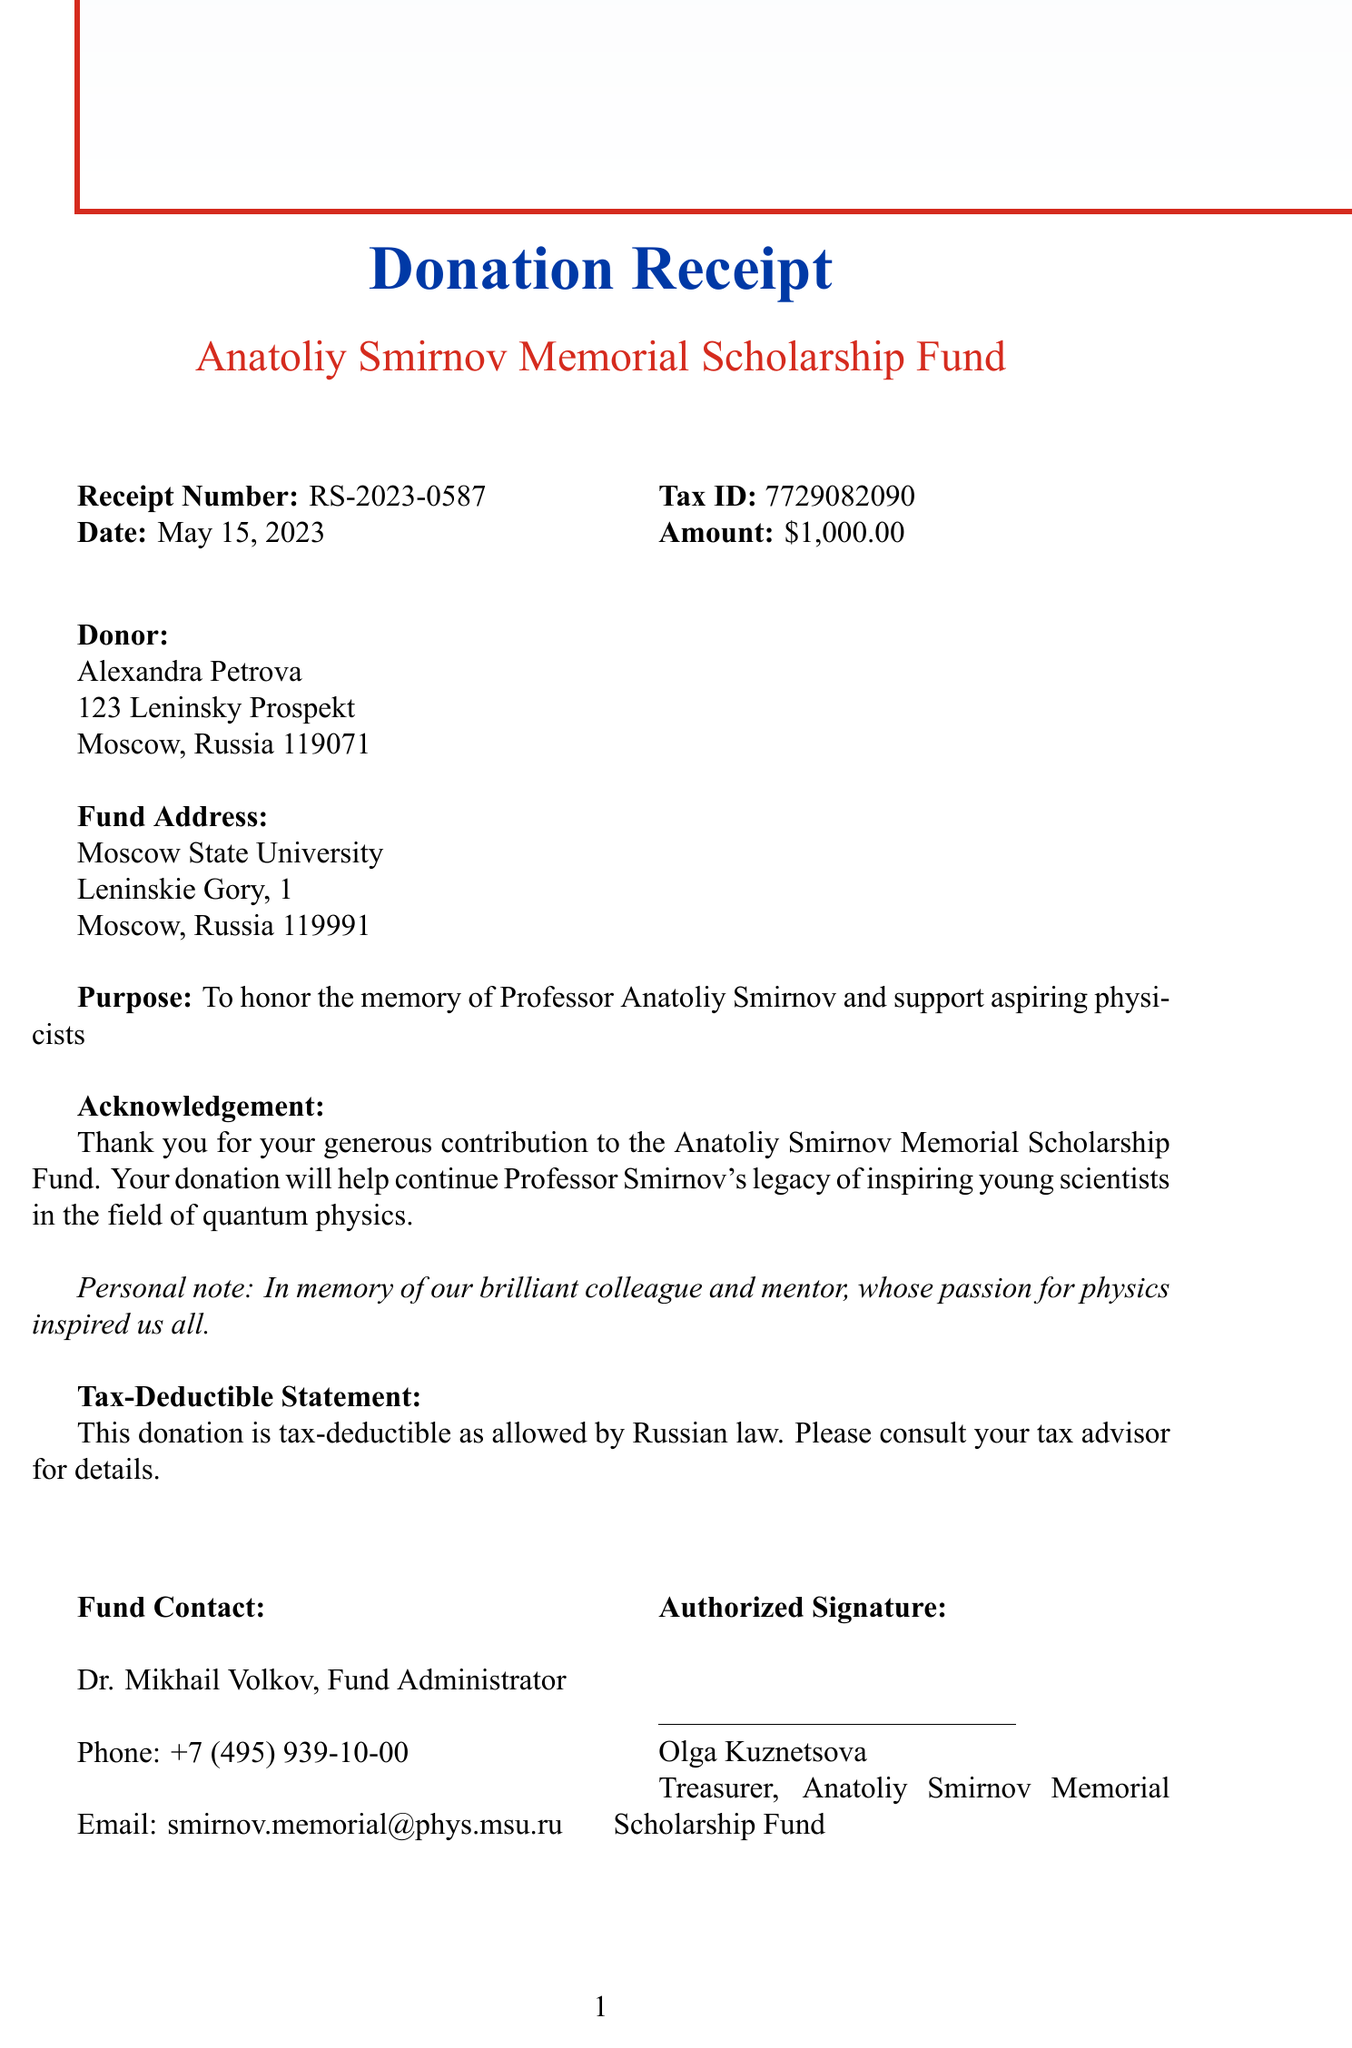What is the receipt number? The receipt number is explicitly listed in the document to identify the transaction.
Answer: RS-2023-0587 Who is the donor? The document specifies the name of the person who made the donation.
Answer: Alexandra Petrova What is the donation amount? The donation amount is clearly stated in the document as part of the financial details.
Answer: $1,000.00 What is the purpose of the donation? The purpose clarifies why the donation was made and is highlighted in the document.
Answer: To honor the memory of Professor Anatoliy Smirnov and support aspiring physicists Who is the authorized signer of the receipt? The authorized signer's name is provided at the end of the document as the person responsible for the receipt.
Answer: Olga Kuznetsova When was the donation made? The date of the donation is given in the document, indicating when the contribution was received.
Answer: May 15, 2023 What is the tax ID number? The tax ID number is a unique identifier mentioned in the document and is necessary for tax purposes.
Answer: 7729082090 What organization does the donation support? The name of the fund that benefits from the donation is mentioned in the document.
Answer: Anatoliy Smirnov Memorial Scholarship Fund What type of document is this? The document is categorized based on its structure and purpose, directly identifying it.
Answer: Donation Receipt 